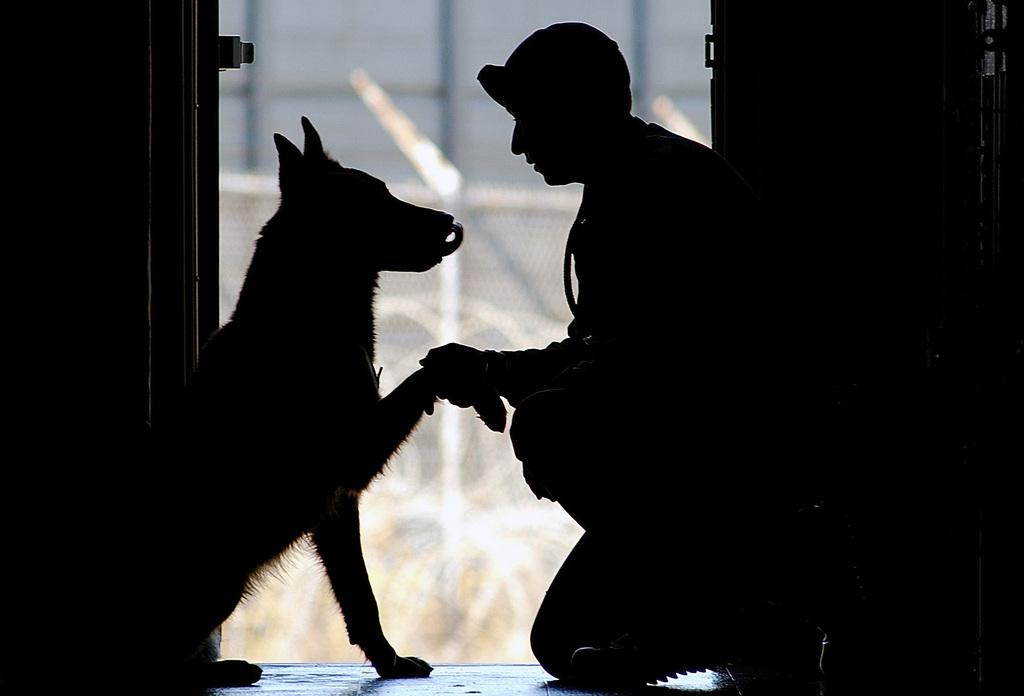What type of animal is in the image? There is a dog in the image. Who else is in the image besides the dog? There is a man in the image. What are the dog and the man doing in the image? The dog and the man are hand shaking each other. What is the color of the photograph? The photograph is completely black. What type of berry is the dog holding in its mouth in the image? There is no berry present in the image; the dog is hand shaking the man. 